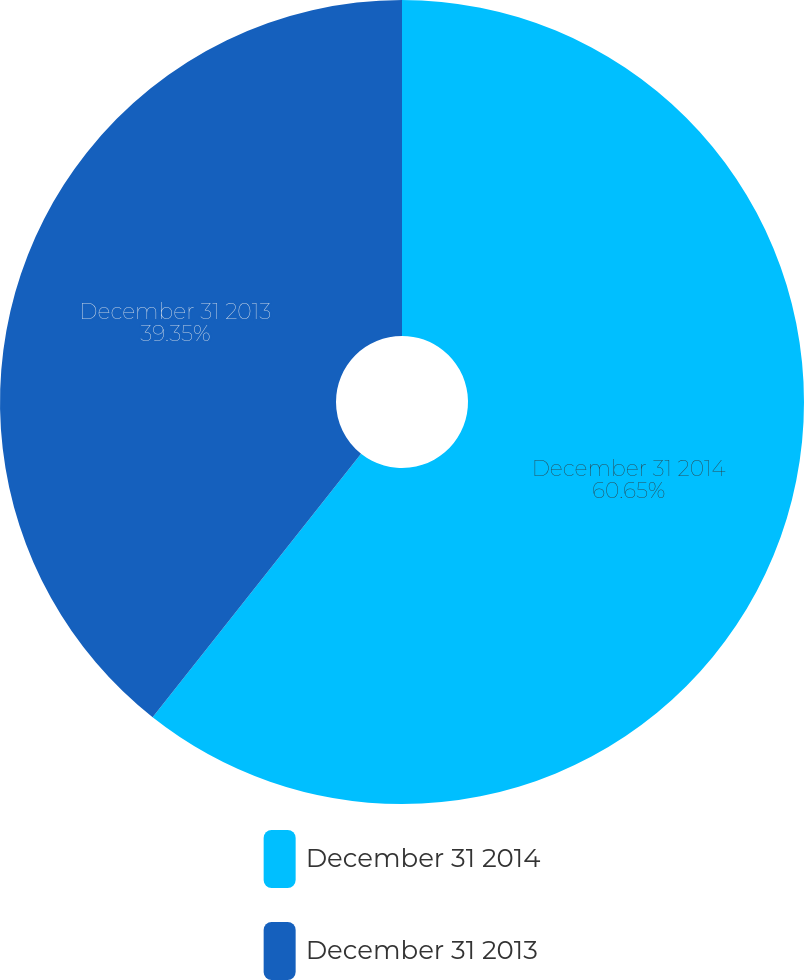Convert chart. <chart><loc_0><loc_0><loc_500><loc_500><pie_chart><fcel>December 31 2014<fcel>December 31 2013<nl><fcel>60.65%<fcel>39.35%<nl></chart> 